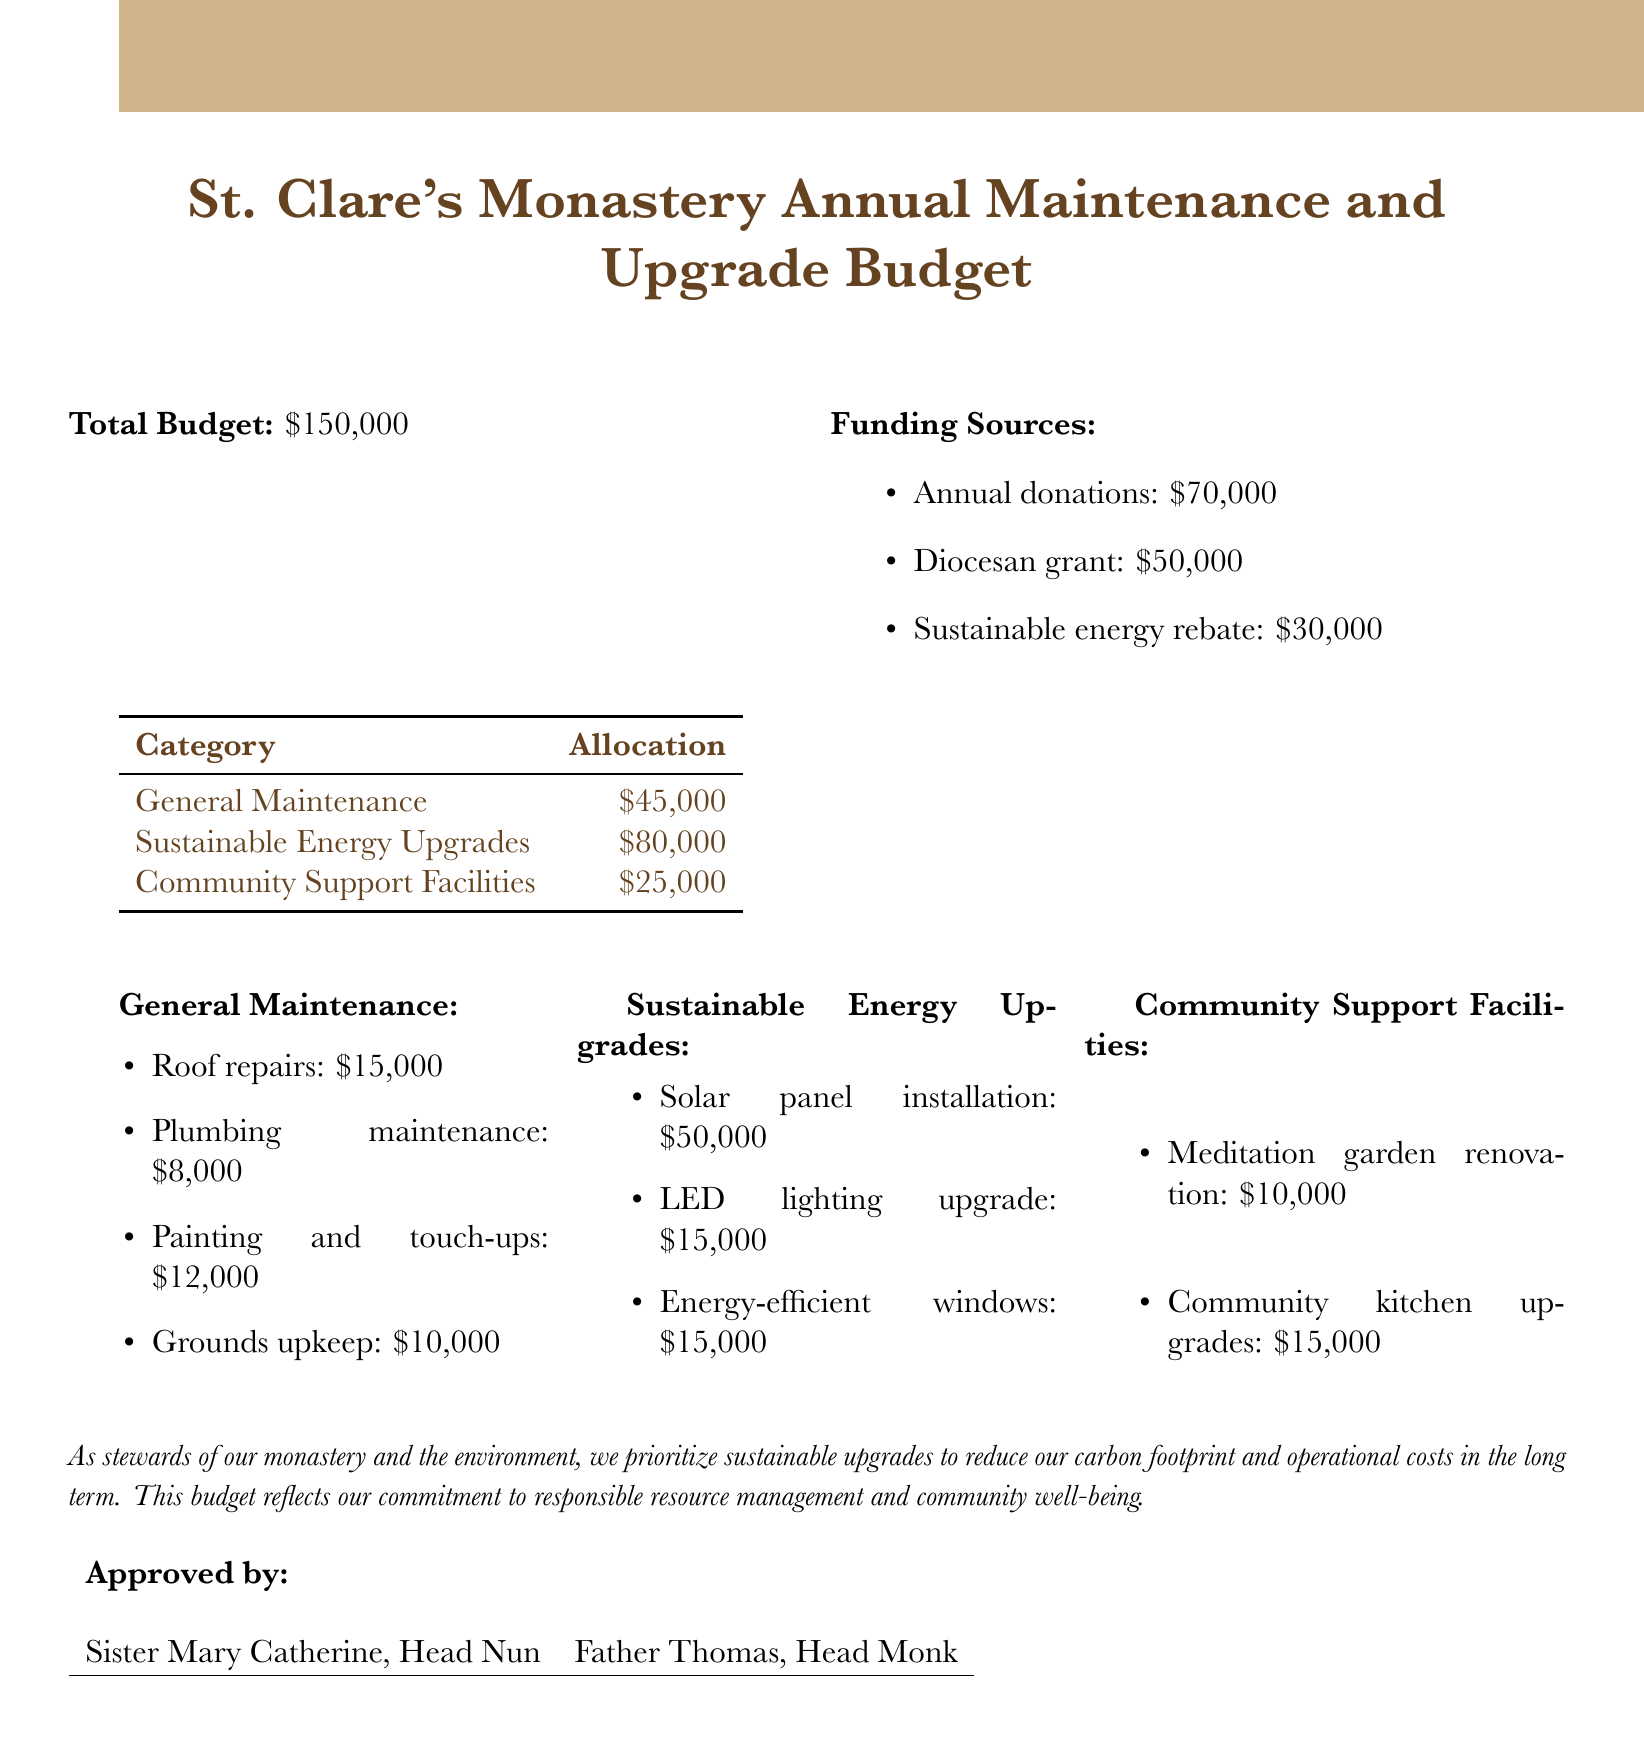What is the total budget? The total budget is stated at the beginning of the document as $150,000.
Answer: $150,000 How much is allocated for sustainable energy upgrades? The allocation for sustainable energy upgrades is provided in the budget summary.
Answer: $80,000 What is the amount for roof repairs? The specific amount for roof repairs is listed under general maintenance in the budget breakdown.
Answer: $15,000 Who is the head nun? The document mentions Sister Mary Catherine as the Head Nun in the approval section.
Answer: Sister Mary Catherine How much is received from annual donations? The funding source section details that annual donations contribute $70,000 to the budget.
Answer: $70,000 What is the total allocation for community support facilities? The total allocation for community support facilities is found by adding the respective amounts listed under that category.
Answer: $25,000 What is one of the sustainable energy upgrades mentioned? The document lists solar panel installation as one of the sustainable energy upgrades.
Answer: Solar panel installation How much is allocated for plumbing maintenance? Plumbing maintenance is specifically allocated in the general maintenance section of the budget.
Answer: $8,000 What is the purpose of the sustainable energy upgrades? The purpose is articulated in the document, emphasizing responsibilities towards the environment and cost reduction.
Answer: Reduce carbon footprint 